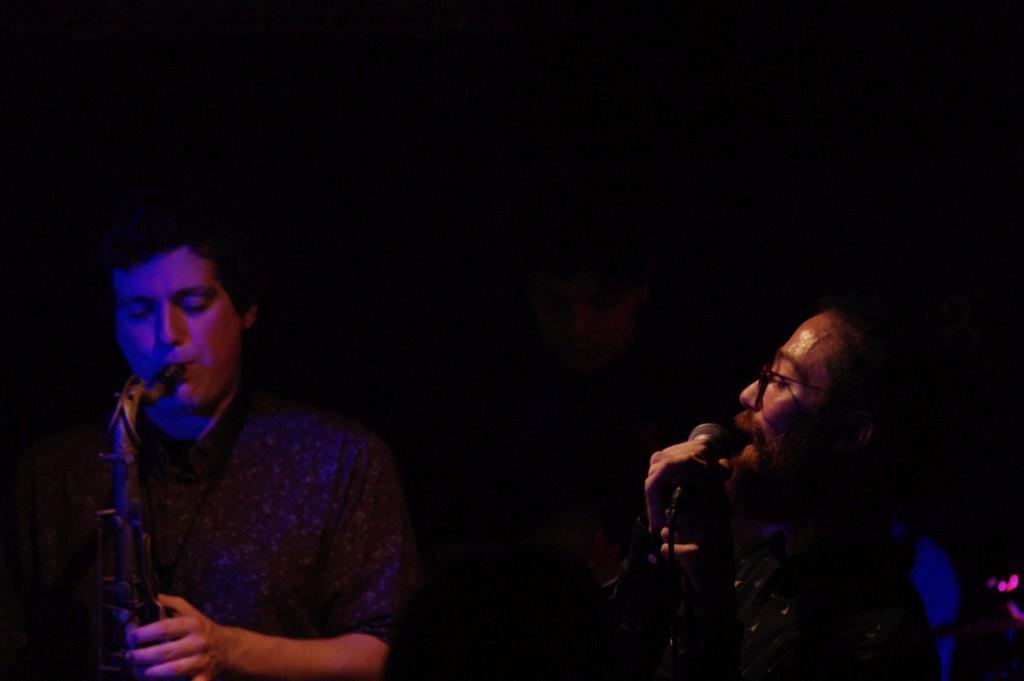How many people are in the image? There are two men in the image. What are the men doing in the image? The men are holding and playing musical instruments. What can be observed about the background of the image? The background of the image is dark. What type of marble is being used as a prop in the image? There is no marble present in the image; the men are holding and playing musical instruments. 